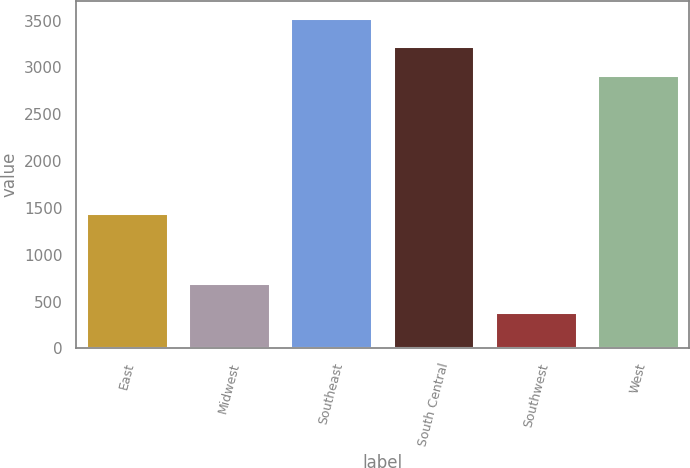Convert chart. <chart><loc_0><loc_0><loc_500><loc_500><bar_chart><fcel>East<fcel>Midwest<fcel>Southeast<fcel>South Central<fcel>Southwest<fcel>West<nl><fcel>1446.5<fcel>695.64<fcel>3531.98<fcel>3224.44<fcel>388.1<fcel>2916.9<nl></chart> 